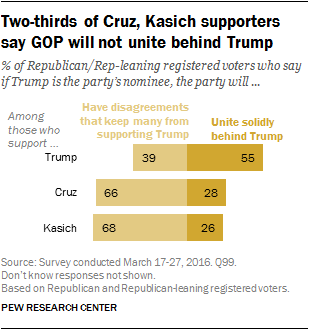Give some essential details in this illustration. The average value of "united solidly behind Trump" is 36.33. The highest amount in the orange bar is 55. 